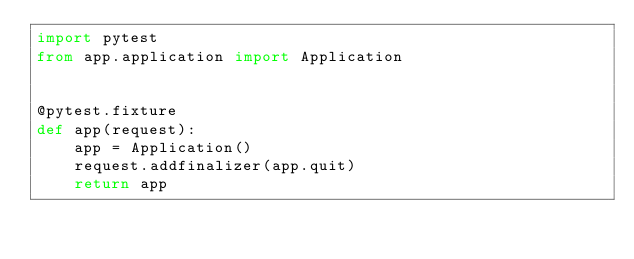<code> <loc_0><loc_0><loc_500><loc_500><_Python_>import pytest
from app.application import Application


@pytest.fixture
def app(request):
    app = Application()
    request.addfinalizer(app.quit)
    return app
</code> 